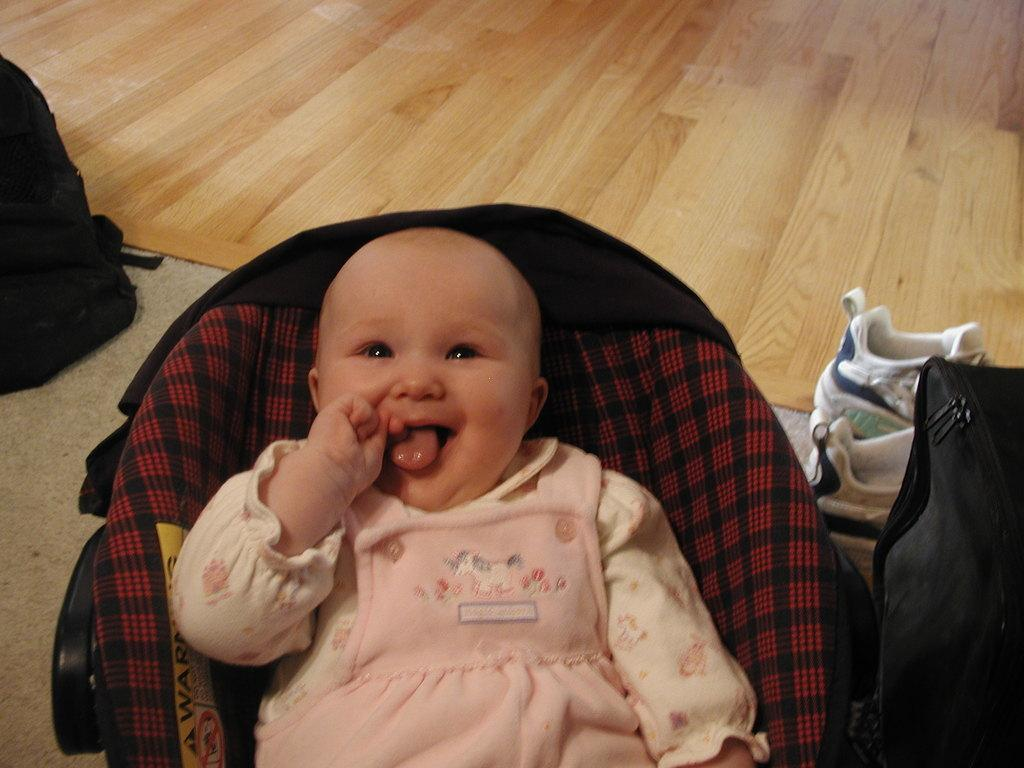What type of flooring is visible in the image? There is a wooden floor in the image. What object can be seen in the image that might be used for carrying items? There is a bag in the image. What type of footwear is visible in the image? There are shoes in the image. What material is present in the image that might be used for clothing or decoration? There is cloth in the image. What type of furniture is visible in the image? There are chairs in the image. Who is present in the image? There is a child in the image. What color is the dress the child is wearing? The child is wearing a pink dress. What type of lace can be seen on the playground equipment in the image? There is no playground equipment or lace present in the image. What type of pancake is being served to the child in the image? There is no pancake present in the image. 